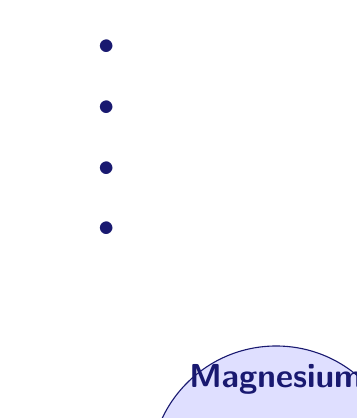Give your solution to this math problem. To solve this problem, we'll use the principle of inclusion-exclusion for three sets. Let's define our sets:

$A$: Patients taking Vitamin D
$B$: Patients taking Omega-3
$C$: Patients taking Magnesium

We're given:
$|A| = 45$, $|B| = 30$, $|C| = 25$
$|A \cap B| = 15$, $|A \cap C| = 10$, $|B \cap C| = 8$
$|A \cap B \cap C| = 5$

The formula for the union of three sets is:

$$|A \cup B \cup C| = |A| + |B| + |C| - |A \cap B| - |A \cap C| - |B \cap C| + |A \cap B \cap C|$$

Let's substitute our values:

$$|A \cup B \cup C| = 45 + 30 + 25 - 15 - 10 - 8 + 5$$

Now, let's calculate:

$$|A \cup B \cup C| = 100 - 33 + 5 = 72$$

Therefore, 72 patients are taking at least one of these supplements.
Answer: 72 patients 